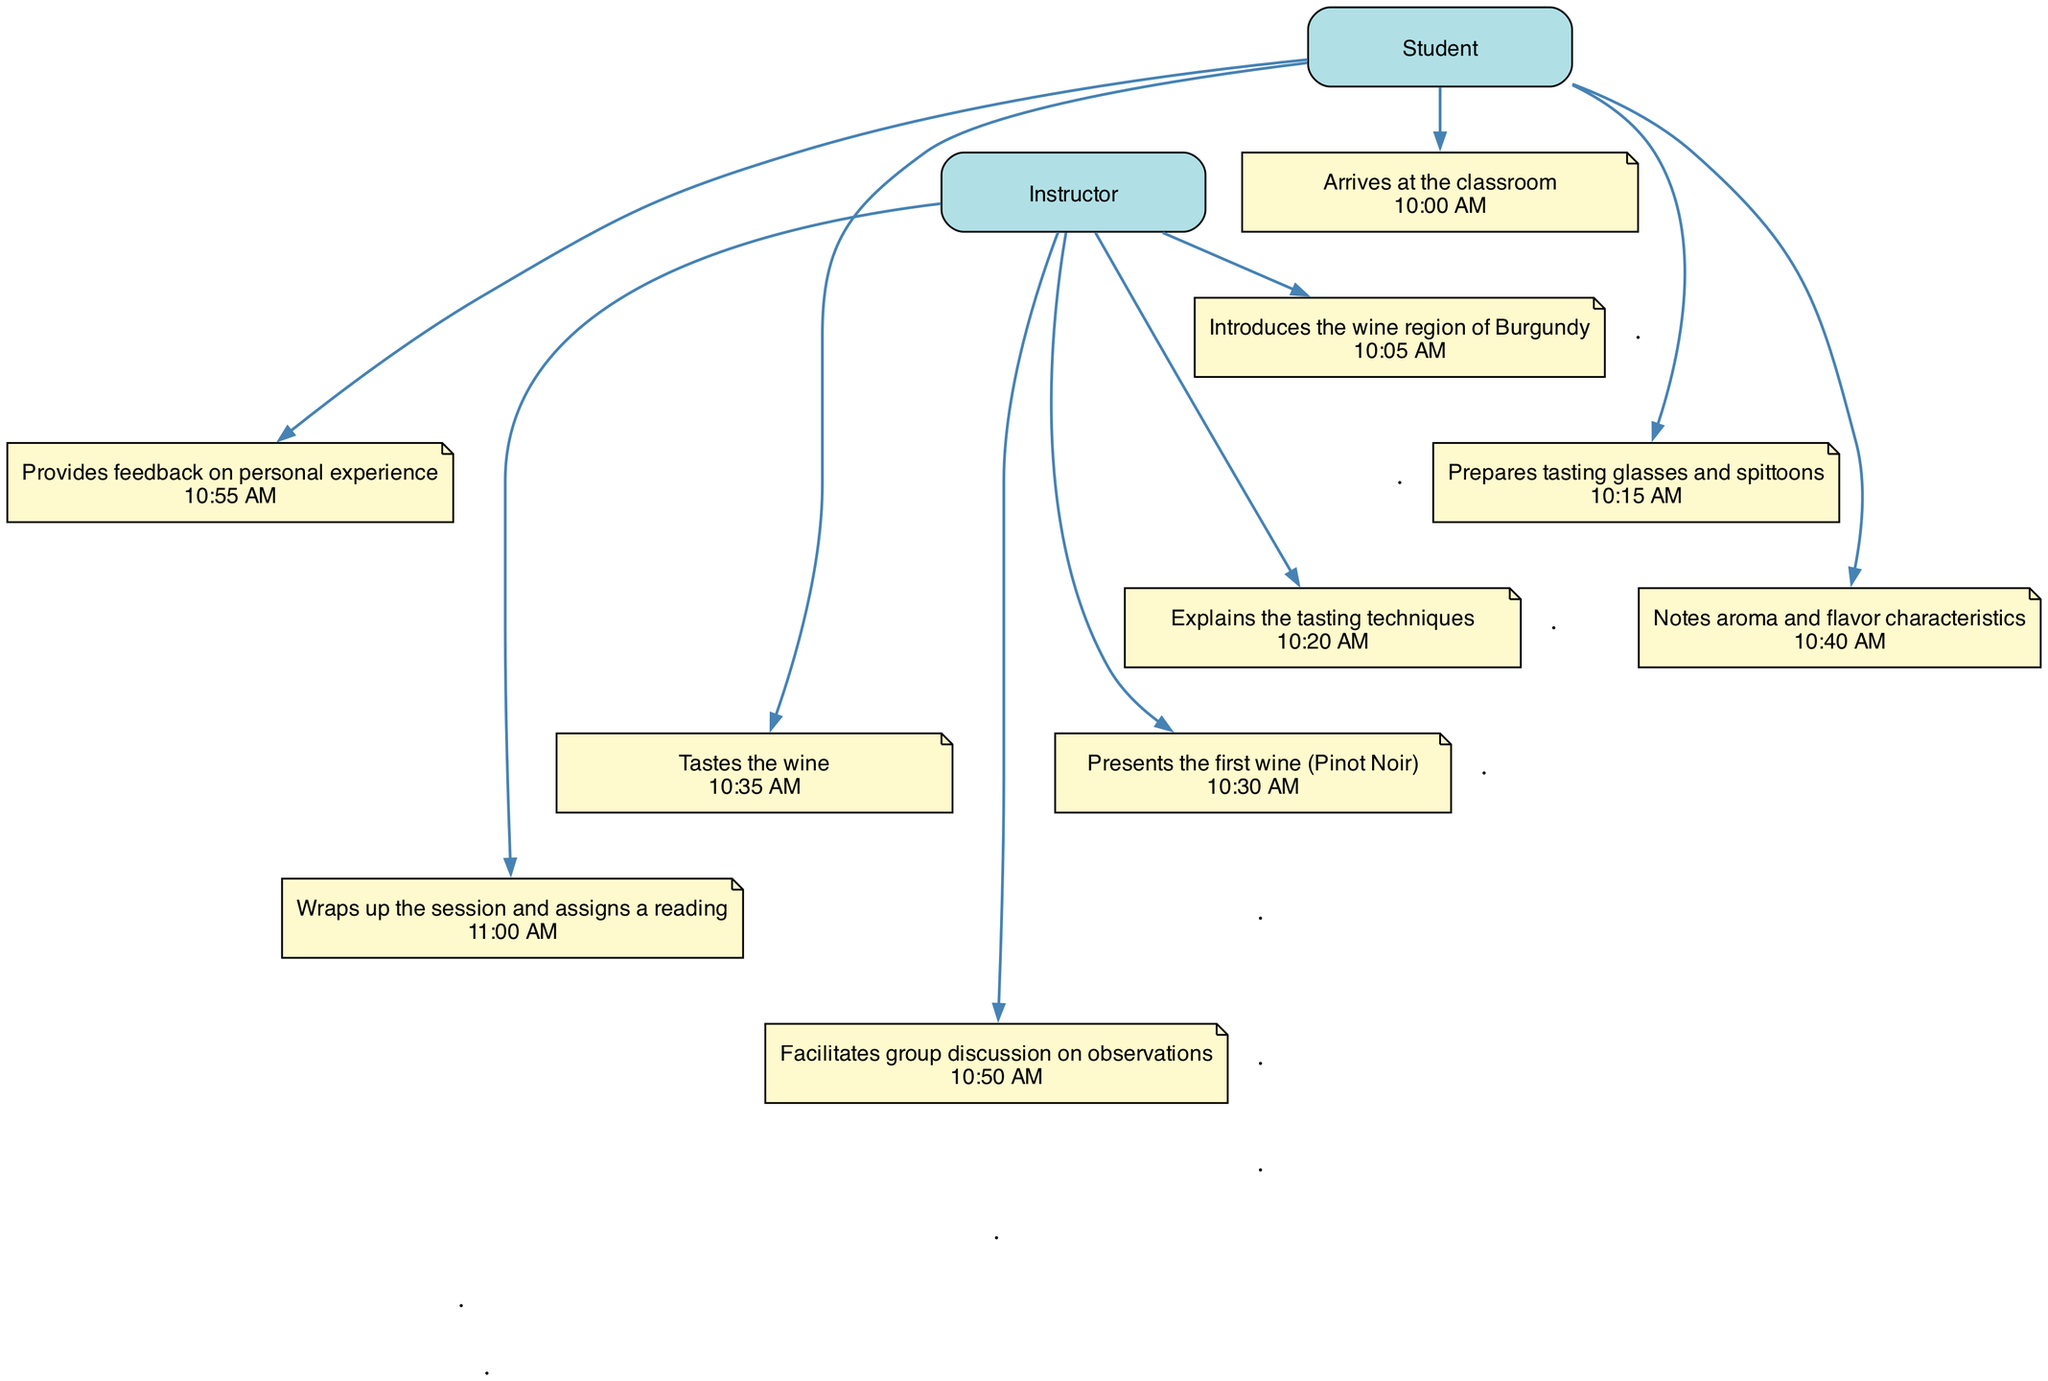What time does the class start? The diagram indicates that the student arrives at the classroom at 10:00 AM, which marks the start of the class.
Answer: 10:00 AM How many actions are performed by the instructor? By counting the actions attributed to the instructor in the diagram, we find there are four distinct actions performed: introducing the wine region, explaining tasting techniques, presenting the first wine, and wrapping up the session.
Answer: 4 What is the first wine presented in the class? In the sequence diagram, the instructor presents Pinot Noir first during the tasting session.
Answer: Pinot Noir At what time does the student begin tasting the wine? According to the timeline in the diagram, the student starts tasting the wine at 10:35 AM, following the presentation of the first wine.
Answer: 10:35 AM What action immediately follows the student noting aroma and flavor characteristics? After the student notes aroma and flavor characteristics, the instructor facilitates a group discussion on observations, as per the sequence flow in the diagram.
Answer: Facilitates group discussion on observations How many distinct actors are involved in this sequence? By reviewing the roles specified in the diagram, we see there are two actors involved: the Student and the Instructor, which are explicitly mentioned in the actions.
Answer: 2 What is the time interval between the presentation of the first wine and the student providing feedback? The first wine is presented at 10:30 AM, and the student provides feedback at 10:55 AM. The time interval can be calculated as 25 minutes from the presentation to when feedback is given.
Answer: 25 minutes Which actor prepares the tasting glasses and spittoons? The diagram reflects that the student is the one who prepares the tasting glasses and spittoons, indicating their role in the class's preparation.
Answer: Student What action occurs just before the instructor wraps up the session? Before the instructor wraps up the session, there is a group discussion facilitated by the instructor, allowing students to share their observations and experiences.
Answer: Facilitates group discussion on observations 